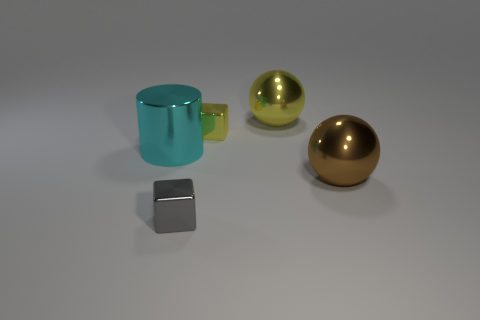Add 2 small matte balls. How many objects exist? 7 Subtract all cylinders. How many objects are left? 4 Subtract 0 cyan balls. How many objects are left? 5 Subtract all big yellow metallic balls. Subtract all blue matte cubes. How many objects are left? 4 Add 2 cyan cylinders. How many cyan cylinders are left? 3 Add 5 small red metal spheres. How many small red metal spheres exist? 5 